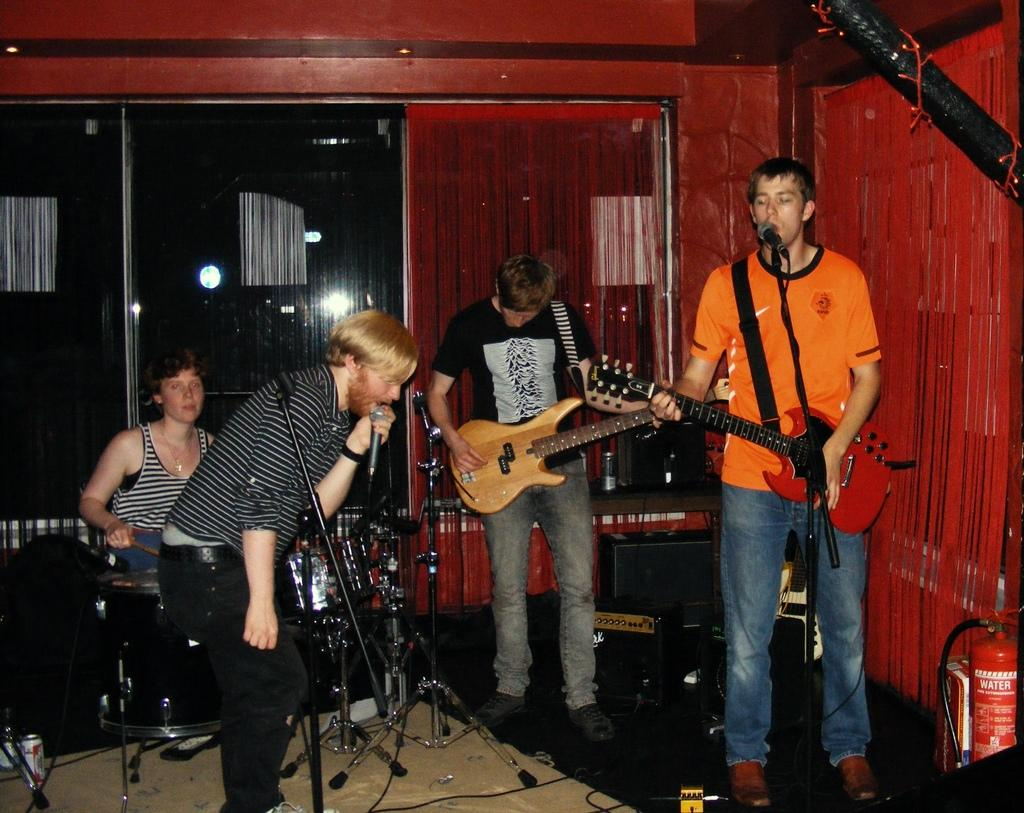What are the people in the image doing? The people in the image are singing and playing musical instruments. What type of setting is the scene taking place in? The scene takes place in a room. What feature can be seen on the walls of the room? There are glass windows in the room, which are part of the wall. What type of baseball equipment can be seen in the image? There is no baseball equipment present in the image. Who is the owner of the musical instruments in the image? The image does not provide information about the ownership of the musical instruments. 